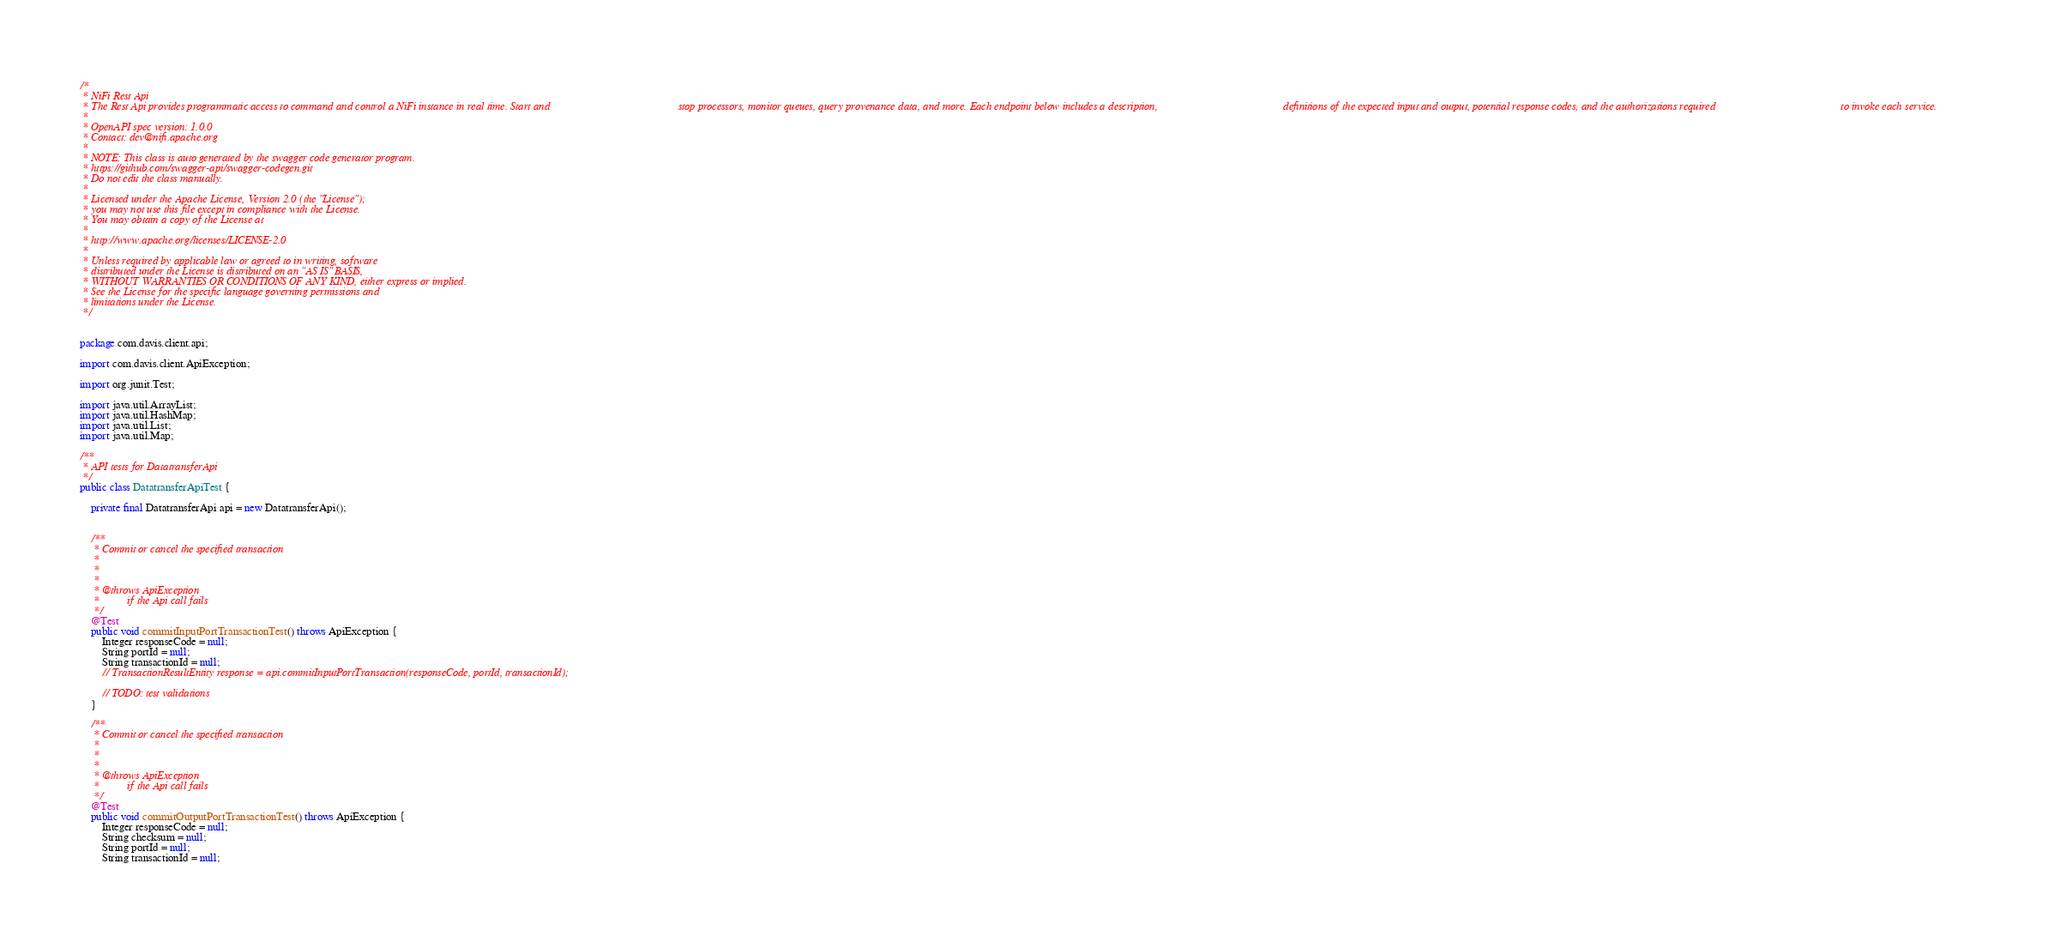<code> <loc_0><loc_0><loc_500><loc_500><_Java_>/*
 * NiFi Rest Api
 * The Rest Api provides programmatic access to command and control a NiFi instance in real time. Start and                                              stop processors, monitor queues, query provenance data, and more. Each endpoint below includes a description,                                             definitions of the expected input and output, potential response codes, and the authorizations required                                             to invoke each service.
 *
 * OpenAPI spec version: 1.0.0
 * Contact: dev@nifi.apache.org
 *
 * NOTE: This class is auto generated by the swagger code generator program.
 * https://github.com/swagger-api/swagger-codegen.git
 * Do not edit the class manually.
 *
 * Licensed under the Apache License, Version 2.0 (the "License");
 * you may not use this file except in compliance with the License.
 * You may obtain a copy of the License at
 *
 * http://www.apache.org/licenses/LICENSE-2.0
 *
 * Unless required by applicable law or agreed to in writing, software
 * distributed under the License is distributed on an "AS IS" BASIS,
 * WITHOUT WARRANTIES OR CONDITIONS OF ANY KIND, either express or implied.
 * See the License for the specific language governing permissions and
 * limitations under the License.
 */


package com.davis.client.api;

import com.davis.client.ApiException;

import org.junit.Test;

import java.util.ArrayList;
import java.util.HashMap;
import java.util.List;
import java.util.Map;

/**
 * API tests for DatatransferApi
 */
public class DatatransferApiTest {

    private final DatatransferApi api = new DatatransferApi();

    
    /**
     * Commit or cancel the specified transaction
     *
     * 
     *
     * @throws ApiException
     *          if the Api call fails
     */
    @Test
    public void commitInputPortTransactionTest() throws ApiException {
        Integer responseCode = null;
        String portId = null;
        String transactionId = null;
        // TransactionResultEntity response = api.commitInputPortTransaction(responseCode, portId, transactionId);

        // TODO: test validations
    }
    
    /**
     * Commit or cancel the specified transaction
     *
     * 
     *
     * @throws ApiException
     *          if the Api call fails
     */
    @Test
    public void commitOutputPortTransactionTest() throws ApiException {
        Integer responseCode = null;
        String checksum = null;
        String portId = null;
        String transactionId = null;</code> 